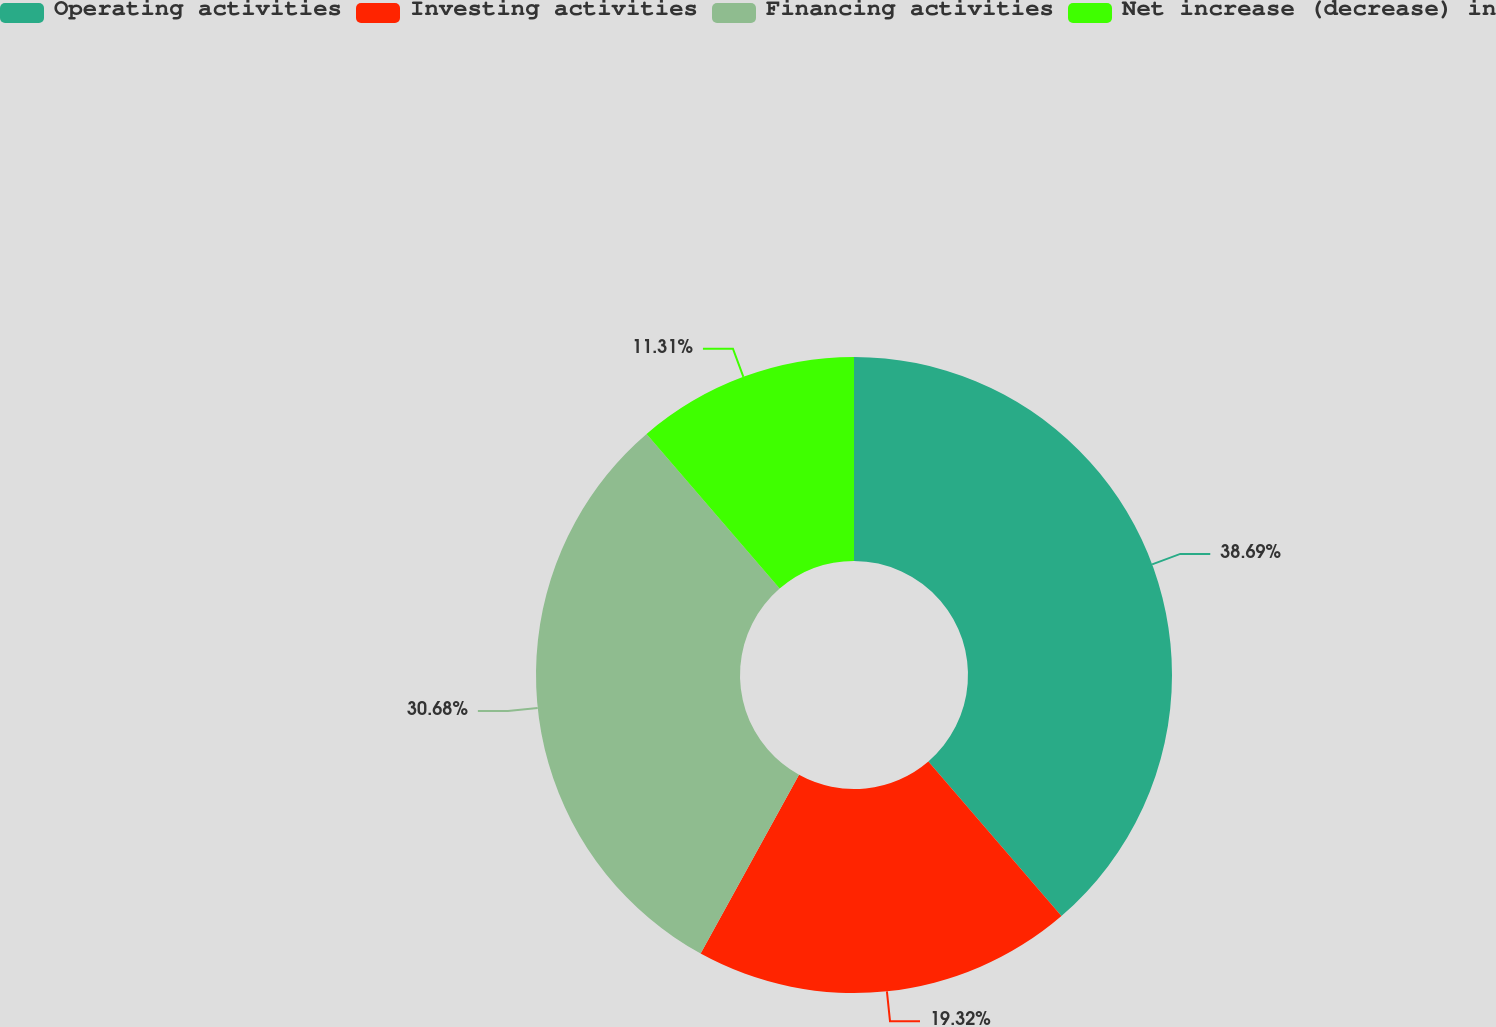Convert chart to OTSL. <chart><loc_0><loc_0><loc_500><loc_500><pie_chart><fcel>Operating activities<fcel>Investing activities<fcel>Financing activities<fcel>Net increase (decrease) in<nl><fcel>38.69%<fcel>19.32%<fcel>30.68%<fcel>11.31%<nl></chart> 